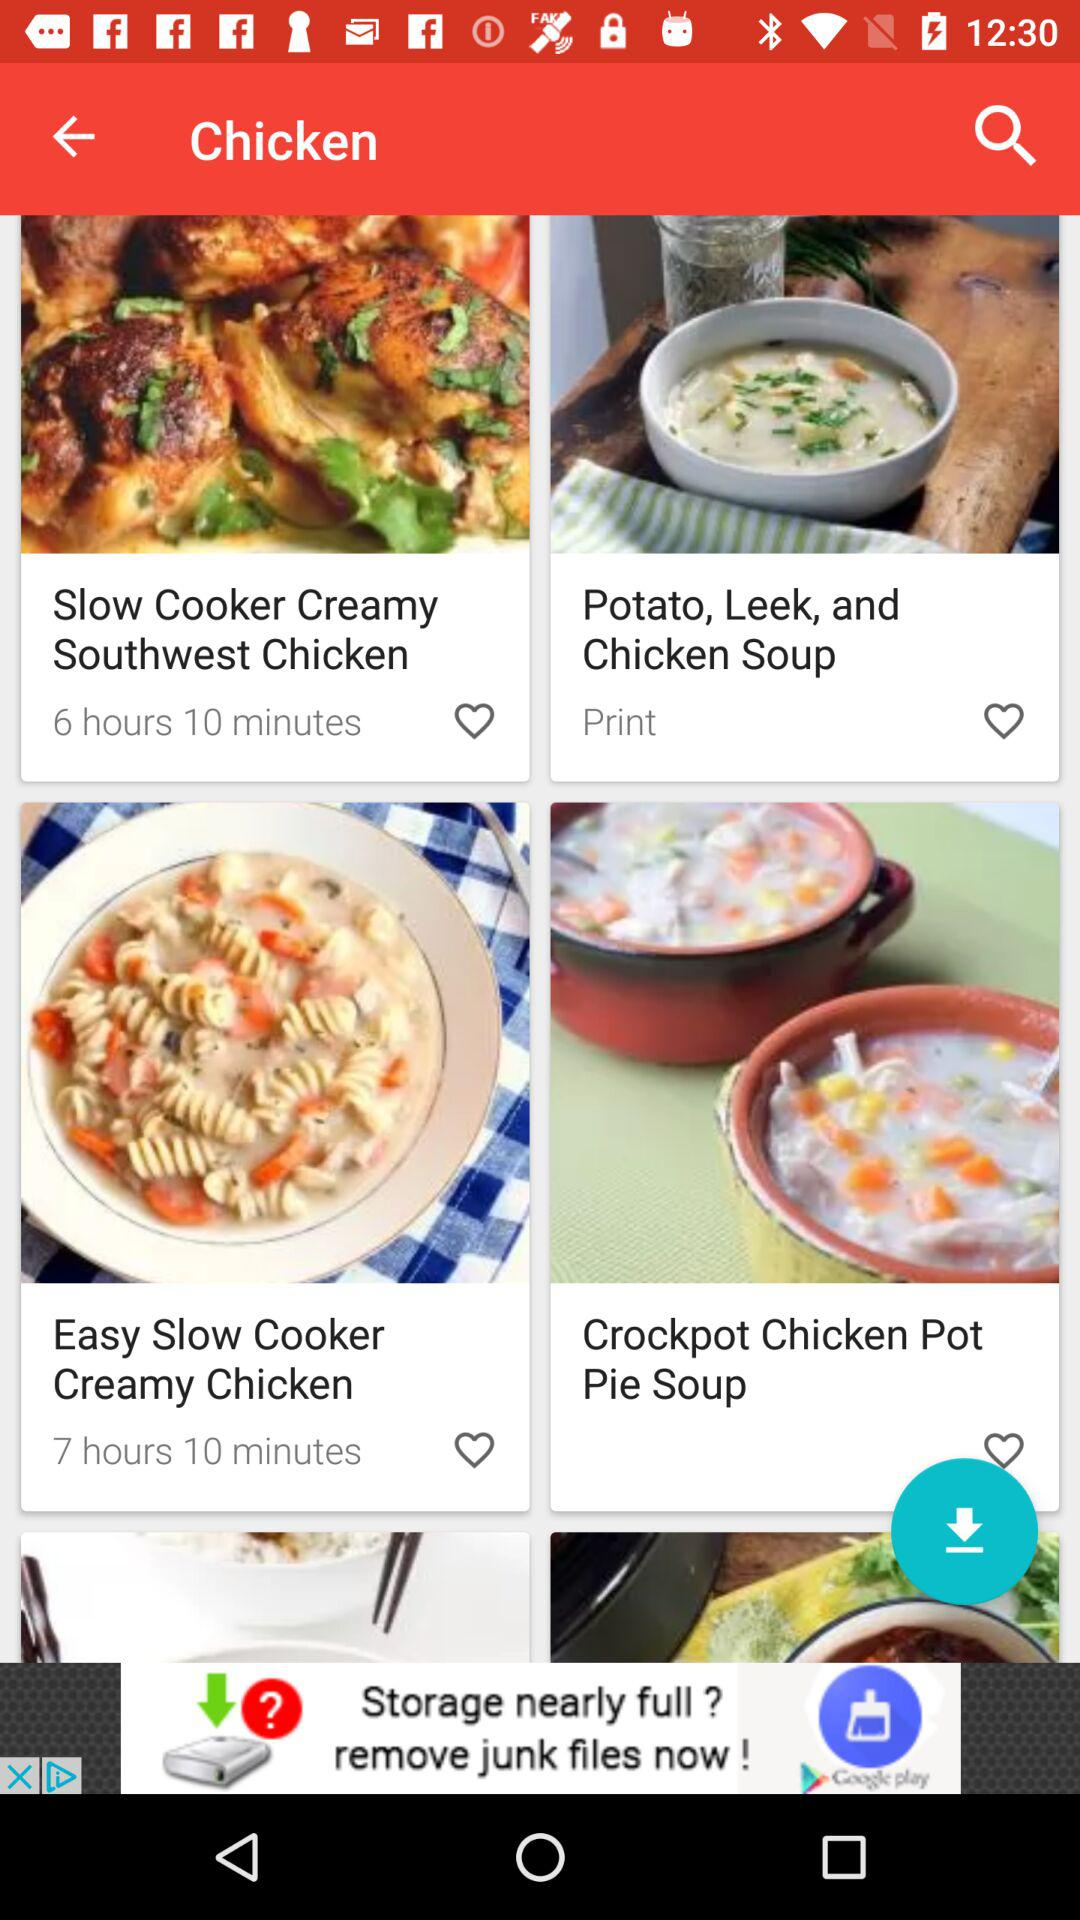How many recipes are in the chicken category?
Answer the question using a single word or phrase. 4 